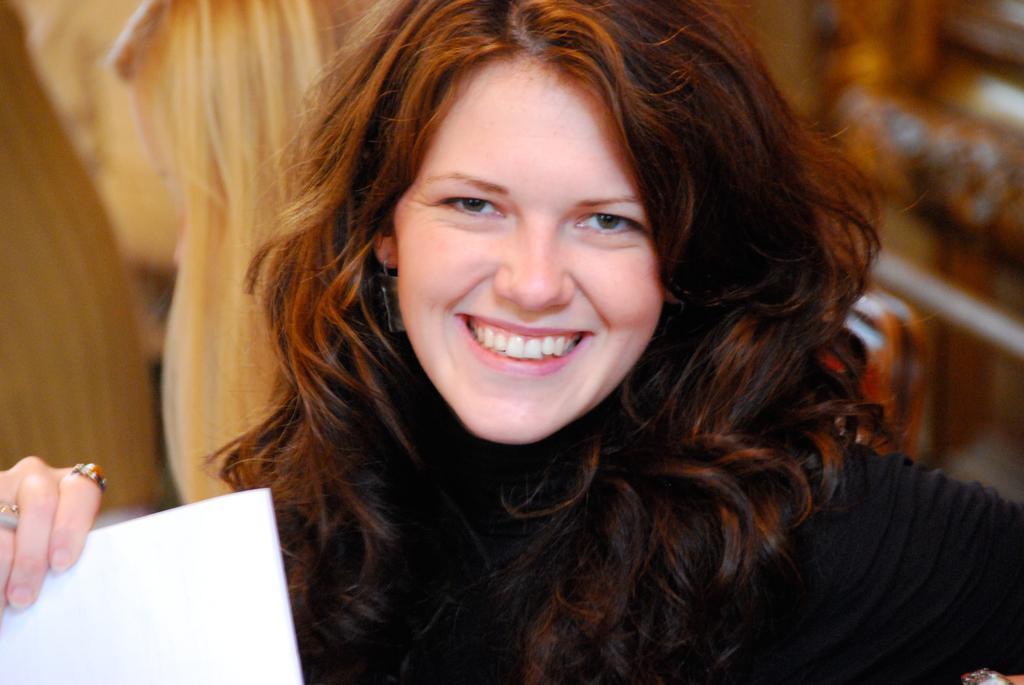Describe this image in one or two sentences. In this image there is a person holding an object, the background of the image is blurred. 